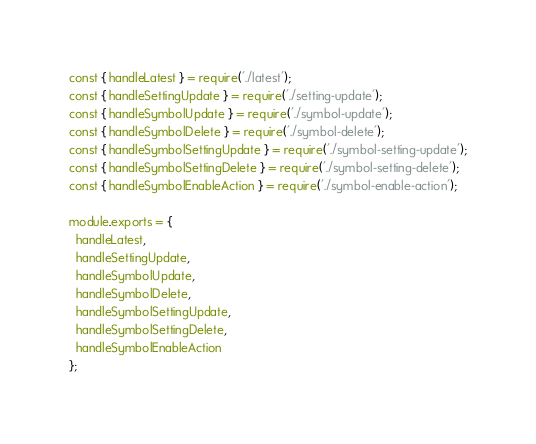Convert code to text. <code><loc_0><loc_0><loc_500><loc_500><_JavaScript_>const { handleLatest } = require('./latest');
const { handleSettingUpdate } = require('./setting-update');
const { handleSymbolUpdate } = require('./symbol-update');
const { handleSymbolDelete } = require('./symbol-delete');
const { handleSymbolSettingUpdate } = require('./symbol-setting-update');
const { handleSymbolSettingDelete } = require('./symbol-setting-delete');
const { handleSymbolEnableAction } = require('./symbol-enable-action');

module.exports = {
  handleLatest,
  handleSettingUpdate,
  handleSymbolUpdate,
  handleSymbolDelete,
  handleSymbolSettingUpdate,
  handleSymbolSettingDelete,
  handleSymbolEnableAction
};
</code> 